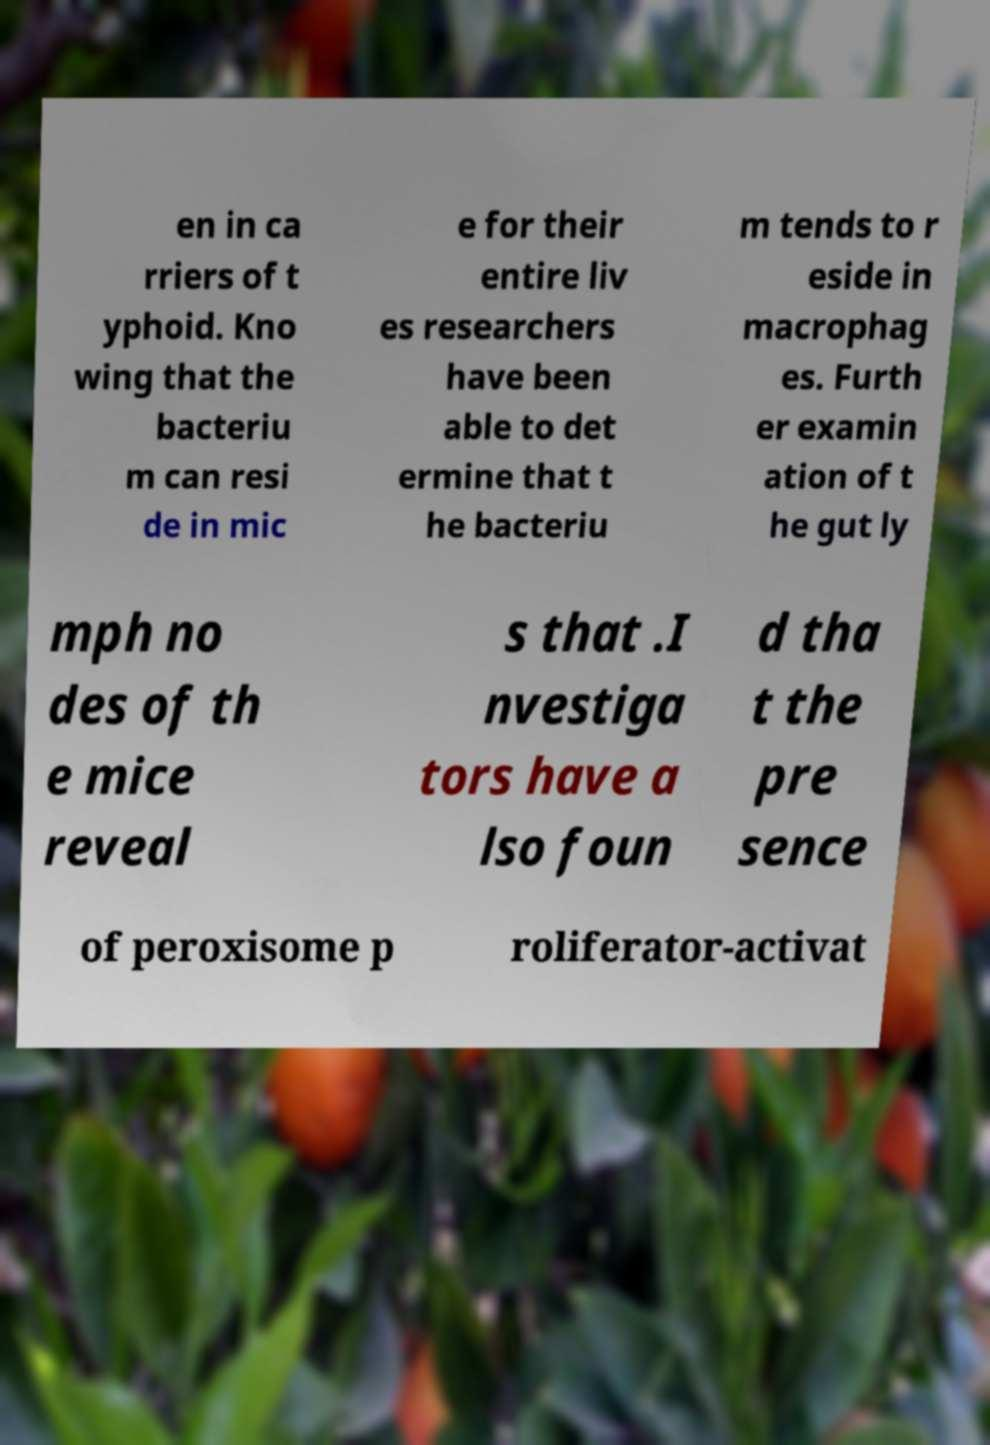I need the written content from this picture converted into text. Can you do that? en in ca rriers of t yphoid. Kno wing that the bacteriu m can resi de in mic e for their entire liv es researchers have been able to det ermine that t he bacteriu m tends to r eside in macrophag es. Furth er examin ation of t he gut ly mph no des of th e mice reveal s that .I nvestiga tors have a lso foun d tha t the pre sence of peroxisome p roliferator-activat 